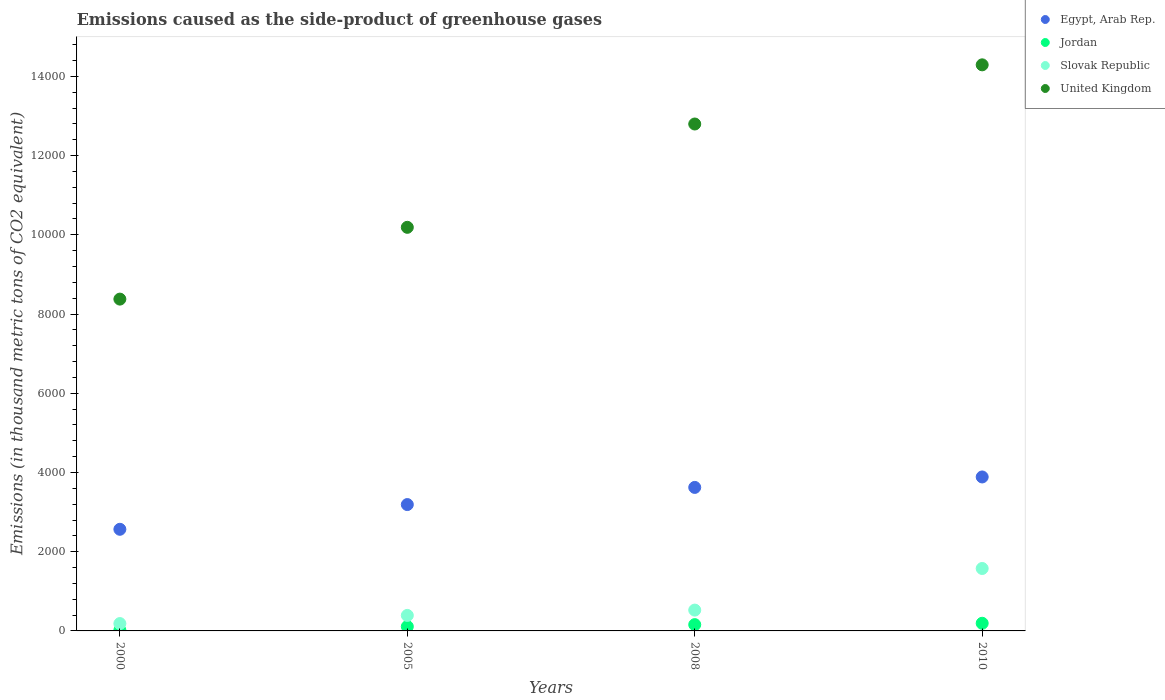What is the emissions caused as the side-product of greenhouse gases in Jordan in 2000?
Your answer should be very brief. 19.7. Across all years, what is the maximum emissions caused as the side-product of greenhouse gases in Jordan?
Ensure brevity in your answer.  193. What is the total emissions caused as the side-product of greenhouse gases in Slovak Republic in the graph?
Your answer should be very brief. 2678.7. What is the difference between the emissions caused as the side-product of greenhouse gases in Egypt, Arab Rep. in 2000 and that in 2008?
Make the answer very short. -1057.2. What is the difference between the emissions caused as the side-product of greenhouse gases in Slovak Republic in 2005 and the emissions caused as the side-product of greenhouse gases in Egypt, Arab Rep. in 2008?
Give a very brief answer. -3231.5. What is the average emissions caused as the side-product of greenhouse gases in Egypt, Arab Rep. per year?
Offer a very short reply. 3316.3. In the year 2005, what is the difference between the emissions caused as the side-product of greenhouse gases in United Kingdom and emissions caused as the side-product of greenhouse gases in Slovak Republic?
Provide a short and direct response. 9797.7. In how many years, is the emissions caused as the side-product of greenhouse gases in Slovak Republic greater than 2000 thousand metric tons?
Offer a terse response. 0. What is the ratio of the emissions caused as the side-product of greenhouse gases in Egypt, Arab Rep. in 2005 to that in 2008?
Provide a short and direct response. 0.88. Is the emissions caused as the side-product of greenhouse gases in Jordan in 2005 less than that in 2008?
Keep it short and to the point. Yes. Is the difference between the emissions caused as the side-product of greenhouse gases in United Kingdom in 2000 and 2008 greater than the difference between the emissions caused as the side-product of greenhouse gases in Slovak Republic in 2000 and 2008?
Offer a terse response. No. What is the difference between the highest and the second highest emissions caused as the side-product of greenhouse gases in Egypt, Arab Rep.?
Ensure brevity in your answer.  264.2. What is the difference between the highest and the lowest emissions caused as the side-product of greenhouse gases in Egypt, Arab Rep.?
Provide a short and direct response. 1321.4. In how many years, is the emissions caused as the side-product of greenhouse gases in Egypt, Arab Rep. greater than the average emissions caused as the side-product of greenhouse gases in Egypt, Arab Rep. taken over all years?
Your answer should be compact. 2. Does the emissions caused as the side-product of greenhouse gases in United Kingdom monotonically increase over the years?
Your answer should be very brief. Yes. Is the emissions caused as the side-product of greenhouse gases in Jordan strictly greater than the emissions caused as the side-product of greenhouse gases in Slovak Republic over the years?
Provide a succinct answer. No. How many dotlines are there?
Offer a very short reply. 4. How many years are there in the graph?
Make the answer very short. 4. Are the values on the major ticks of Y-axis written in scientific E-notation?
Offer a very short reply. No. Does the graph contain any zero values?
Your answer should be compact. No. Does the graph contain grids?
Provide a short and direct response. No. How many legend labels are there?
Offer a terse response. 4. How are the legend labels stacked?
Provide a succinct answer. Vertical. What is the title of the graph?
Offer a terse response. Emissions caused as the side-product of greenhouse gases. Does "Finland" appear as one of the legend labels in the graph?
Offer a very short reply. No. What is the label or title of the X-axis?
Make the answer very short. Years. What is the label or title of the Y-axis?
Your response must be concise. Emissions (in thousand metric tons of CO2 equivalent). What is the Emissions (in thousand metric tons of CO2 equivalent) of Egypt, Arab Rep. in 2000?
Your response must be concise. 2565.6. What is the Emissions (in thousand metric tons of CO2 equivalent) in Slovak Republic in 2000?
Your answer should be compact. 185.6. What is the Emissions (in thousand metric tons of CO2 equivalent) in United Kingdom in 2000?
Give a very brief answer. 8376.7. What is the Emissions (in thousand metric tons of CO2 equivalent) in Egypt, Arab Rep. in 2005?
Give a very brief answer. 3189.8. What is the Emissions (in thousand metric tons of CO2 equivalent) of Jordan in 2005?
Offer a very short reply. 110.3. What is the Emissions (in thousand metric tons of CO2 equivalent) of Slovak Republic in 2005?
Your response must be concise. 391.3. What is the Emissions (in thousand metric tons of CO2 equivalent) in United Kingdom in 2005?
Your response must be concise. 1.02e+04. What is the Emissions (in thousand metric tons of CO2 equivalent) of Egypt, Arab Rep. in 2008?
Ensure brevity in your answer.  3622.8. What is the Emissions (in thousand metric tons of CO2 equivalent) of Jordan in 2008?
Give a very brief answer. 158.8. What is the Emissions (in thousand metric tons of CO2 equivalent) of Slovak Republic in 2008?
Your response must be concise. 525.8. What is the Emissions (in thousand metric tons of CO2 equivalent) of United Kingdom in 2008?
Give a very brief answer. 1.28e+04. What is the Emissions (in thousand metric tons of CO2 equivalent) of Egypt, Arab Rep. in 2010?
Your response must be concise. 3887. What is the Emissions (in thousand metric tons of CO2 equivalent) in Jordan in 2010?
Ensure brevity in your answer.  193. What is the Emissions (in thousand metric tons of CO2 equivalent) of Slovak Republic in 2010?
Make the answer very short. 1576. What is the Emissions (in thousand metric tons of CO2 equivalent) in United Kingdom in 2010?
Offer a very short reply. 1.43e+04. Across all years, what is the maximum Emissions (in thousand metric tons of CO2 equivalent) in Egypt, Arab Rep.?
Give a very brief answer. 3887. Across all years, what is the maximum Emissions (in thousand metric tons of CO2 equivalent) in Jordan?
Provide a short and direct response. 193. Across all years, what is the maximum Emissions (in thousand metric tons of CO2 equivalent) of Slovak Republic?
Offer a very short reply. 1576. Across all years, what is the maximum Emissions (in thousand metric tons of CO2 equivalent) of United Kingdom?
Provide a succinct answer. 1.43e+04. Across all years, what is the minimum Emissions (in thousand metric tons of CO2 equivalent) of Egypt, Arab Rep.?
Provide a short and direct response. 2565.6. Across all years, what is the minimum Emissions (in thousand metric tons of CO2 equivalent) in Slovak Republic?
Give a very brief answer. 185.6. Across all years, what is the minimum Emissions (in thousand metric tons of CO2 equivalent) of United Kingdom?
Provide a short and direct response. 8376.7. What is the total Emissions (in thousand metric tons of CO2 equivalent) of Egypt, Arab Rep. in the graph?
Your answer should be very brief. 1.33e+04. What is the total Emissions (in thousand metric tons of CO2 equivalent) in Jordan in the graph?
Your answer should be compact. 481.8. What is the total Emissions (in thousand metric tons of CO2 equivalent) of Slovak Republic in the graph?
Provide a succinct answer. 2678.7. What is the total Emissions (in thousand metric tons of CO2 equivalent) of United Kingdom in the graph?
Give a very brief answer. 4.57e+04. What is the difference between the Emissions (in thousand metric tons of CO2 equivalent) in Egypt, Arab Rep. in 2000 and that in 2005?
Give a very brief answer. -624.2. What is the difference between the Emissions (in thousand metric tons of CO2 equivalent) in Jordan in 2000 and that in 2005?
Your response must be concise. -90.6. What is the difference between the Emissions (in thousand metric tons of CO2 equivalent) of Slovak Republic in 2000 and that in 2005?
Your response must be concise. -205.7. What is the difference between the Emissions (in thousand metric tons of CO2 equivalent) in United Kingdom in 2000 and that in 2005?
Your answer should be very brief. -1812.3. What is the difference between the Emissions (in thousand metric tons of CO2 equivalent) of Egypt, Arab Rep. in 2000 and that in 2008?
Offer a terse response. -1057.2. What is the difference between the Emissions (in thousand metric tons of CO2 equivalent) in Jordan in 2000 and that in 2008?
Your response must be concise. -139.1. What is the difference between the Emissions (in thousand metric tons of CO2 equivalent) in Slovak Republic in 2000 and that in 2008?
Keep it short and to the point. -340.2. What is the difference between the Emissions (in thousand metric tons of CO2 equivalent) in United Kingdom in 2000 and that in 2008?
Your response must be concise. -4420.6. What is the difference between the Emissions (in thousand metric tons of CO2 equivalent) of Egypt, Arab Rep. in 2000 and that in 2010?
Make the answer very short. -1321.4. What is the difference between the Emissions (in thousand metric tons of CO2 equivalent) in Jordan in 2000 and that in 2010?
Provide a succinct answer. -173.3. What is the difference between the Emissions (in thousand metric tons of CO2 equivalent) in Slovak Republic in 2000 and that in 2010?
Give a very brief answer. -1390.4. What is the difference between the Emissions (in thousand metric tons of CO2 equivalent) in United Kingdom in 2000 and that in 2010?
Make the answer very short. -5914.3. What is the difference between the Emissions (in thousand metric tons of CO2 equivalent) of Egypt, Arab Rep. in 2005 and that in 2008?
Your answer should be very brief. -433. What is the difference between the Emissions (in thousand metric tons of CO2 equivalent) of Jordan in 2005 and that in 2008?
Make the answer very short. -48.5. What is the difference between the Emissions (in thousand metric tons of CO2 equivalent) in Slovak Republic in 2005 and that in 2008?
Your response must be concise. -134.5. What is the difference between the Emissions (in thousand metric tons of CO2 equivalent) of United Kingdom in 2005 and that in 2008?
Ensure brevity in your answer.  -2608.3. What is the difference between the Emissions (in thousand metric tons of CO2 equivalent) of Egypt, Arab Rep. in 2005 and that in 2010?
Keep it short and to the point. -697.2. What is the difference between the Emissions (in thousand metric tons of CO2 equivalent) in Jordan in 2005 and that in 2010?
Make the answer very short. -82.7. What is the difference between the Emissions (in thousand metric tons of CO2 equivalent) of Slovak Republic in 2005 and that in 2010?
Provide a short and direct response. -1184.7. What is the difference between the Emissions (in thousand metric tons of CO2 equivalent) of United Kingdom in 2005 and that in 2010?
Offer a very short reply. -4102. What is the difference between the Emissions (in thousand metric tons of CO2 equivalent) of Egypt, Arab Rep. in 2008 and that in 2010?
Ensure brevity in your answer.  -264.2. What is the difference between the Emissions (in thousand metric tons of CO2 equivalent) in Jordan in 2008 and that in 2010?
Offer a terse response. -34.2. What is the difference between the Emissions (in thousand metric tons of CO2 equivalent) of Slovak Republic in 2008 and that in 2010?
Keep it short and to the point. -1050.2. What is the difference between the Emissions (in thousand metric tons of CO2 equivalent) in United Kingdom in 2008 and that in 2010?
Your answer should be very brief. -1493.7. What is the difference between the Emissions (in thousand metric tons of CO2 equivalent) of Egypt, Arab Rep. in 2000 and the Emissions (in thousand metric tons of CO2 equivalent) of Jordan in 2005?
Your answer should be compact. 2455.3. What is the difference between the Emissions (in thousand metric tons of CO2 equivalent) of Egypt, Arab Rep. in 2000 and the Emissions (in thousand metric tons of CO2 equivalent) of Slovak Republic in 2005?
Keep it short and to the point. 2174.3. What is the difference between the Emissions (in thousand metric tons of CO2 equivalent) in Egypt, Arab Rep. in 2000 and the Emissions (in thousand metric tons of CO2 equivalent) in United Kingdom in 2005?
Make the answer very short. -7623.4. What is the difference between the Emissions (in thousand metric tons of CO2 equivalent) of Jordan in 2000 and the Emissions (in thousand metric tons of CO2 equivalent) of Slovak Republic in 2005?
Give a very brief answer. -371.6. What is the difference between the Emissions (in thousand metric tons of CO2 equivalent) in Jordan in 2000 and the Emissions (in thousand metric tons of CO2 equivalent) in United Kingdom in 2005?
Offer a very short reply. -1.02e+04. What is the difference between the Emissions (in thousand metric tons of CO2 equivalent) in Slovak Republic in 2000 and the Emissions (in thousand metric tons of CO2 equivalent) in United Kingdom in 2005?
Give a very brief answer. -1.00e+04. What is the difference between the Emissions (in thousand metric tons of CO2 equivalent) of Egypt, Arab Rep. in 2000 and the Emissions (in thousand metric tons of CO2 equivalent) of Jordan in 2008?
Offer a terse response. 2406.8. What is the difference between the Emissions (in thousand metric tons of CO2 equivalent) of Egypt, Arab Rep. in 2000 and the Emissions (in thousand metric tons of CO2 equivalent) of Slovak Republic in 2008?
Ensure brevity in your answer.  2039.8. What is the difference between the Emissions (in thousand metric tons of CO2 equivalent) of Egypt, Arab Rep. in 2000 and the Emissions (in thousand metric tons of CO2 equivalent) of United Kingdom in 2008?
Make the answer very short. -1.02e+04. What is the difference between the Emissions (in thousand metric tons of CO2 equivalent) of Jordan in 2000 and the Emissions (in thousand metric tons of CO2 equivalent) of Slovak Republic in 2008?
Make the answer very short. -506.1. What is the difference between the Emissions (in thousand metric tons of CO2 equivalent) of Jordan in 2000 and the Emissions (in thousand metric tons of CO2 equivalent) of United Kingdom in 2008?
Provide a succinct answer. -1.28e+04. What is the difference between the Emissions (in thousand metric tons of CO2 equivalent) of Slovak Republic in 2000 and the Emissions (in thousand metric tons of CO2 equivalent) of United Kingdom in 2008?
Provide a short and direct response. -1.26e+04. What is the difference between the Emissions (in thousand metric tons of CO2 equivalent) of Egypt, Arab Rep. in 2000 and the Emissions (in thousand metric tons of CO2 equivalent) of Jordan in 2010?
Keep it short and to the point. 2372.6. What is the difference between the Emissions (in thousand metric tons of CO2 equivalent) of Egypt, Arab Rep. in 2000 and the Emissions (in thousand metric tons of CO2 equivalent) of Slovak Republic in 2010?
Keep it short and to the point. 989.6. What is the difference between the Emissions (in thousand metric tons of CO2 equivalent) in Egypt, Arab Rep. in 2000 and the Emissions (in thousand metric tons of CO2 equivalent) in United Kingdom in 2010?
Provide a succinct answer. -1.17e+04. What is the difference between the Emissions (in thousand metric tons of CO2 equivalent) of Jordan in 2000 and the Emissions (in thousand metric tons of CO2 equivalent) of Slovak Republic in 2010?
Offer a terse response. -1556.3. What is the difference between the Emissions (in thousand metric tons of CO2 equivalent) in Jordan in 2000 and the Emissions (in thousand metric tons of CO2 equivalent) in United Kingdom in 2010?
Your answer should be very brief. -1.43e+04. What is the difference between the Emissions (in thousand metric tons of CO2 equivalent) in Slovak Republic in 2000 and the Emissions (in thousand metric tons of CO2 equivalent) in United Kingdom in 2010?
Keep it short and to the point. -1.41e+04. What is the difference between the Emissions (in thousand metric tons of CO2 equivalent) in Egypt, Arab Rep. in 2005 and the Emissions (in thousand metric tons of CO2 equivalent) in Jordan in 2008?
Make the answer very short. 3031. What is the difference between the Emissions (in thousand metric tons of CO2 equivalent) in Egypt, Arab Rep. in 2005 and the Emissions (in thousand metric tons of CO2 equivalent) in Slovak Republic in 2008?
Make the answer very short. 2664. What is the difference between the Emissions (in thousand metric tons of CO2 equivalent) in Egypt, Arab Rep. in 2005 and the Emissions (in thousand metric tons of CO2 equivalent) in United Kingdom in 2008?
Make the answer very short. -9607.5. What is the difference between the Emissions (in thousand metric tons of CO2 equivalent) in Jordan in 2005 and the Emissions (in thousand metric tons of CO2 equivalent) in Slovak Republic in 2008?
Provide a succinct answer. -415.5. What is the difference between the Emissions (in thousand metric tons of CO2 equivalent) in Jordan in 2005 and the Emissions (in thousand metric tons of CO2 equivalent) in United Kingdom in 2008?
Your answer should be very brief. -1.27e+04. What is the difference between the Emissions (in thousand metric tons of CO2 equivalent) of Slovak Republic in 2005 and the Emissions (in thousand metric tons of CO2 equivalent) of United Kingdom in 2008?
Your response must be concise. -1.24e+04. What is the difference between the Emissions (in thousand metric tons of CO2 equivalent) of Egypt, Arab Rep. in 2005 and the Emissions (in thousand metric tons of CO2 equivalent) of Jordan in 2010?
Offer a very short reply. 2996.8. What is the difference between the Emissions (in thousand metric tons of CO2 equivalent) in Egypt, Arab Rep. in 2005 and the Emissions (in thousand metric tons of CO2 equivalent) in Slovak Republic in 2010?
Your answer should be very brief. 1613.8. What is the difference between the Emissions (in thousand metric tons of CO2 equivalent) in Egypt, Arab Rep. in 2005 and the Emissions (in thousand metric tons of CO2 equivalent) in United Kingdom in 2010?
Your response must be concise. -1.11e+04. What is the difference between the Emissions (in thousand metric tons of CO2 equivalent) in Jordan in 2005 and the Emissions (in thousand metric tons of CO2 equivalent) in Slovak Republic in 2010?
Ensure brevity in your answer.  -1465.7. What is the difference between the Emissions (in thousand metric tons of CO2 equivalent) of Jordan in 2005 and the Emissions (in thousand metric tons of CO2 equivalent) of United Kingdom in 2010?
Keep it short and to the point. -1.42e+04. What is the difference between the Emissions (in thousand metric tons of CO2 equivalent) in Slovak Republic in 2005 and the Emissions (in thousand metric tons of CO2 equivalent) in United Kingdom in 2010?
Give a very brief answer. -1.39e+04. What is the difference between the Emissions (in thousand metric tons of CO2 equivalent) of Egypt, Arab Rep. in 2008 and the Emissions (in thousand metric tons of CO2 equivalent) of Jordan in 2010?
Your response must be concise. 3429.8. What is the difference between the Emissions (in thousand metric tons of CO2 equivalent) of Egypt, Arab Rep. in 2008 and the Emissions (in thousand metric tons of CO2 equivalent) of Slovak Republic in 2010?
Provide a short and direct response. 2046.8. What is the difference between the Emissions (in thousand metric tons of CO2 equivalent) in Egypt, Arab Rep. in 2008 and the Emissions (in thousand metric tons of CO2 equivalent) in United Kingdom in 2010?
Your response must be concise. -1.07e+04. What is the difference between the Emissions (in thousand metric tons of CO2 equivalent) of Jordan in 2008 and the Emissions (in thousand metric tons of CO2 equivalent) of Slovak Republic in 2010?
Make the answer very short. -1417.2. What is the difference between the Emissions (in thousand metric tons of CO2 equivalent) of Jordan in 2008 and the Emissions (in thousand metric tons of CO2 equivalent) of United Kingdom in 2010?
Keep it short and to the point. -1.41e+04. What is the difference between the Emissions (in thousand metric tons of CO2 equivalent) in Slovak Republic in 2008 and the Emissions (in thousand metric tons of CO2 equivalent) in United Kingdom in 2010?
Provide a succinct answer. -1.38e+04. What is the average Emissions (in thousand metric tons of CO2 equivalent) of Egypt, Arab Rep. per year?
Offer a very short reply. 3316.3. What is the average Emissions (in thousand metric tons of CO2 equivalent) in Jordan per year?
Your answer should be compact. 120.45. What is the average Emissions (in thousand metric tons of CO2 equivalent) of Slovak Republic per year?
Ensure brevity in your answer.  669.67. What is the average Emissions (in thousand metric tons of CO2 equivalent) in United Kingdom per year?
Your answer should be very brief. 1.14e+04. In the year 2000, what is the difference between the Emissions (in thousand metric tons of CO2 equivalent) in Egypt, Arab Rep. and Emissions (in thousand metric tons of CO2 equivalent) in Jordan?
Offer a very short reply. 2545.9. In the year 2000, what is the difference between the Emissions (in thousand metric tons of CO2 equivalent) in Egypt, Arab Rep. and Emissions (in thousand metric tons of CO2 equivalent) in Slovak Republic?
Offer a terse response. 2380. In the year 2000, what is the difference between the Emissions (in thousand metric tons of CO2 equivalent) in Egypt, Arab Rep. and Emissions (in thousand metric tons of CO2 equivalent) in United Kingdom?
Make the answer very short. -5811.1. In the year 2000, what is the difference between the Emissions (in thousand metric tons of CO2 equivalent) in Jordan and Emissions (in thousand metric tons of CO2 equivalent) in Slovak Republic?
Your answer should be compact. -165.9. In the year 2000, what is the difference between the Emissions (in thousand metric tons of CO2 equivalent) of Jordan and Emissions (in thousand metric tons of CO2 equivalent) of United Kingdom?
Keep it short and to the point. -8357. In the year 2000, what is the difference between the Emissions (in thousand metric tons of CO2 equivalent) of Slovak Republic and Emissions (in thousand metric tons of CO2 equivalent) of United Kingdom?
Make the answer very short. -8191.1. In the year 2005, what is the difference between the Emissions (in thousand metric tons of CO2 equivalent) of Egypt, Arab Rep. and Emissions (in thousand metric tons of CO2 equivalent) of Jordan?
Offer a terse response. 3079.5. In the year 2005, what is the difference between the Emissions (in thousand metric tons of CO2 equivalent) in Egypt, Arab Rep. and Emissions (in thousand metric tons of CO2 equivalent) in Slovak Republic?
Offer a terse response. 2798.5. In the year 2005, what is the difference between the Emissions (in thousand metric tons of CO2 equivalent) in Egypt, Arab Rep. and Emissions (in thousand metric tons of CO2 equivalent) in United Kingdom?
Offer a terse response. -6999.2. In the year 2005, what is the difference between the Emissions (in thousand metric tons of CO2 equivalent) in Jordan and Emissions (in thousand metric tons of CO2 equivalent) in Slovak Republic?
Give a very brief answer. -281. In the year 2005, what is the difference between the Emissions (in thousand metric tons of CO2 equivalent) of Jordan and Emissions (in thousand metric tons of CO2 equivalent) of United Kingdom?
Your answer should be very brief. -1.01e+04. In the year 2005, what is the difference between the Emissions (in thousand metric tons of CO2 equivalent) of Slovak Republic and Emissions (in thousand metric tons of CO2 equivalent) of United Kingdom?
Your answer should be very brief. -9797.7. In the year 2008, what is the difference between the Emissions (in thousand metric tons of CO2 equivalent) of Egypt, Arab Rep. and Emissions (in thousand metric tons of CO2 equivalent) of Jordan?
Offer a terse response. 3464. In the year 2008, what is the difference between the Emissions (in thousand metric tons of CO2 equivalent) of Egypt, Arab Rep. and Emissions (in thousand metric tons of CO2 equivalent) of Slovak Republic?
Make the answer very short. 3097. In the year 2008, what is the difference between the Emissions (in thousand metric tons of CO2 equivalent) in Egypt, Arab Rep. and Emissions (in thousand metric tons of CO2 equivalent) in United Kingdom?
Your answer should be very brief. -9174.5. In the year 2008, what is the difference between the Emissions (in thousand metric tons of CO2 equivalent) in Jordan and Emissions (in thousand metric tons of CO2 equivalent) in Slovak Republic?
Give a very brief answer. -367. In the year 2008, what is the difference between the Emissions (in thousand metric tons of CO2 equivalent) in Jordan and Emissions (in thousand metric tons of CO2 equivalent) in United Kingdom?
Provide a succinct answer. -1.26e+04. In the year 2008, what is the difference between the Emissions (in thousand metric tons of CO2 equivalent) in Slovak Republic and Emissions (in thousand metric tons of CO2 equivalent) in United Kingdom?
Keep it short and to the point. -1.23e+04. In the year 2010, what is the difference between the Emissions (in thousand metric tons of CO2 equivalent) in Egypt, Arab Rep. and Emissions (in thousand metric tons of CO2 equivalent) in Jordan?
Make the answer very short. 3694. In the year 2010, what is the difference between the Emissions (in thousand metric tons of CO2 equivalent) of Egypt, Arab Rep. and Emissions (in thousand metric tons of CO2 equivalent) of Slovak Republic?
Offer a very short reply. 2311. In the year 2010, what is the difference between the Emissions (in thousand metric tons of CO2 equivalent) in Egypt, Arab Rep. and Emissions (in thousand metric tons of CO2 equivalent) in United Kingdom?
Offer a very short reply. -1.04e+04. In the year 2010, what is the difference between the Emissions (in thousand metric tons of CO2 equivalent) of Jordan and Emissions (in thousand metric tons of CO2 equivalent) of Slovak Republic?
Make the answer very short. -1383. In the year 2010, what is the difference between the Emissions (in thousand metric tons of CO2 equivalent) of Jordan and Emissions (in thousand metric tons of CO2 equivalent) of United Kingdom?
Make the answer very short. -1.41e+04. In the year 2010, what is the difference between the Emissions (in thousand metric tons of CO2 equivalent) in Slovak Republic and Emissions (in thousand metric tons of CO2 equivalent) in United Kingdom?
Keep it short and to the point. -1.27e+04. What is the ratio of the Emissions (in thousand metric tons of CO2 equivalent) of Egypt, Arab Rep. in 2000 to that in 2005?
Give a very brief answer. 0.8. What is the ratio of the Emissions (in thousand metric tons of CO2 equivalent) of Jordan in 2000 to that in 2005?
Your response must be concise. 0.18. What is the ratio of the Emissions (in thousand metric tons of CO2 equivalent) of Slovak Republic in 2000 to that in 2005?
Provide a short and direct response. 0.47. What is the ratio of the Emissions (in thousand metric tons of CO2 equivalent) in United Kingdom in 2000 to that in 2005?
Your answer should be very brief. 0.82. What is the ratio of the Emissions (in thousand metric tons of CO2 equivalent) of Egypt, Arab Rep. in 2000 to that in 2008?
Your answer should be very brief. 0.71. What is the ratio of the Emissions (in thousand metric tons of CO2 equivalent) in Jordan in 2000 to that in 2008?
Keep it short and to the point. 0.12. What is the ratio of the Emissions (in thousand metric tons of CO2 equivalent) of Slovak Republic in 2000 to that in 2008?
Give a very brief answer. 0.35. What is the ratio of the Emissions (in thousand metric tons of CO2 equivalent) in United Kingdom in 2000 to that in 2008?
Make the answer very short. 0.65. What is the ratio of the Emissions (in thousand metric tons of CO2 equivalent) in Egypt, Arab Rep. in 2000 to that in 2010?
Your response must be concise. 0.66. What is the ratio of the Emissions (in thousand metric tons of CO2 equivalent) in Jordan in 2000 to that in 2010?
Give a very brief answer. 0.1. What is the ratio of the Emissions (in thousand metric tons of CO2 equivalent) of Slovak Republic in 2000 to that in 2010?
Provide a short and direct response. 0.12. What is the ratio of the Emissions (in thousand metric tons of CO2 equivalent) of United Kingdom in 2000 to that in 2010?
Provide a succinct answer. 0.59. What is the ratio of the Emissions (in thousand metric tons of CO2 equivalent) of Egypt, Arab Rep. in 2005 to that in 2008?
Offer a terse response. 0.88. What is the ratio of the Emissions (in thousand metric tons of CO2 equivalent) in Jordan in 2005 to that in 2008?
Your response must be concise. 0.69. What is the ratio of the Emissions (in thousand metric tons of CO2 equivalent) in Slovak Republic in 2005 to that in 2008?
Offer a terse response. 0.74. What is the ratio of the Emissions (in thousand metric tons of CO2 equivalent) of United Kingdom in 2005 to that in 2008?
Provide a succinct answer. 0.8. What is the ratio of the Emissions (in thousand metric tons of CO2 equivalent) in Egypt, Arab Rep. in 2005 to that in 2010?
Offer a terse response. 0.82. What is the ratio of the Emissions (in thousand metric tons of CO2 equivalent) of Jordan in 2005 to that in 2010?
Provide a succinct answer. 0.57. What is the ratio of the Emissions (in thousand metric tons of CO2 equivalent) in Slovak Republic in 2005 to that in 2010?
Provide a short and direct response. 0.25. What is the ratio of the Emissions (in thousand metric tons of CO2 equivalent) in United Kingdom in 2005 to that in 2010?
Provide a short and direct response. 0.71. What is the ratio of the Emissions (in thousand metric tons of CO2 equivalent) in Egypt, Arab Rep. in 2008 to that in 2010?
Your answer should be compact. 0.93. What is the ratio of the Emissions (in thousand metric tons of CO2 equivalent) of Jordan in 2008 to that in 2010?
Provide a succinct answer. 0.82. What is the ratio of the Emissions (in thousand metric tons of CO2 equivalent) in Slovak Republic in 2008 to that in 2010?
Offer a very short reply. 0.33. What is the ratio of the Emissions (in thousand metric tons of CO2 equivalent) of United Kingdom in 2008 to that in 2010?
Give a very brief answer. 0.9. What is the difference between the highest and the second highest Emissions (in thousand metric tons of CO2 equivalent) in Egypt, Arab Rep.?
Offer a very short reply. 264.2. What is the difference between the highest and the second highest Emissions (in thousand metric tons of CO2 equivalent) of Jordan?
Offer a terse response. 34.2. What is the difference between the highest and the second highest Emissions (in thousand metric tons of CO2 equivalent) in Slovak Republic?
Make the answer very short. 1050.2. What is the difference between the highest and the second highest Emissions (in thousand metric tons of CO2 equivalent) in United Kingdom?
Your answer should be very brief. 1493.7. What is the difference between the highest and the lowest Emissions (in thousand metric tons of CO2 equivalent) in Egypt, Arab Rep.?
Your answer should be very brief. 1321.4. What is the difference between the highest and the lowest Emissions (in thousand metric tons of CO2 equivalent) in Jordan?
Make the answer very short. 173.3. What is the difference between the highest and the lowest Emissions (in thousand metric tons of CO2 equivalent) in Slovak Republic?
Make the answer very short. 1390.4. What is the difference between the highest and the lowest Emissions (in thousand metric tons of CO2 equivalent) of United Kingdom?
Keep it short and to the point. 5914.3. 